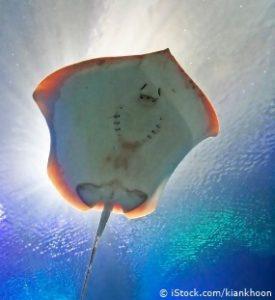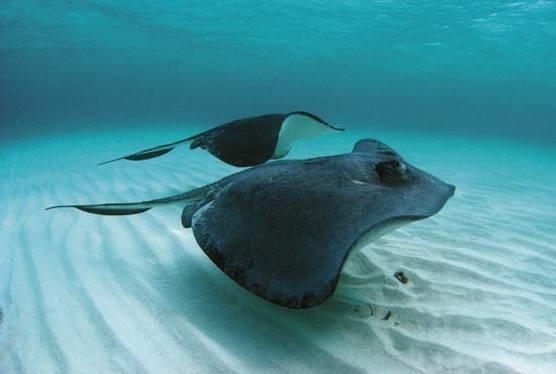The first image is the image on the left, the second image is the image on the right. For the images shown, is this caption "There are at most three stingrays." true? Answer yes or no. Yes. 